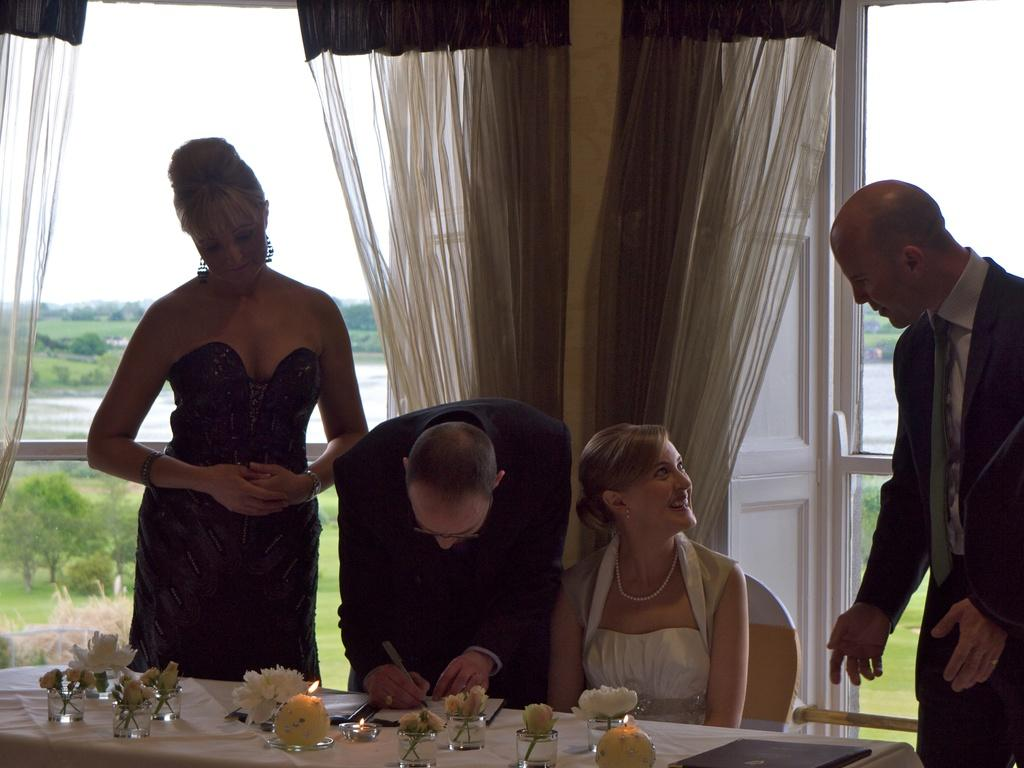How many people are in the image? There are four people in the image, as there are two couples. What are the couples doing in the image? The couples are seated at a table. What type of ducks can be seen playing baseball in the image? There are no ducks or baseball activity present in the image. How many frogs are visible on the table in the image? There are no frogs visible on the table or anywhere else in the image. 